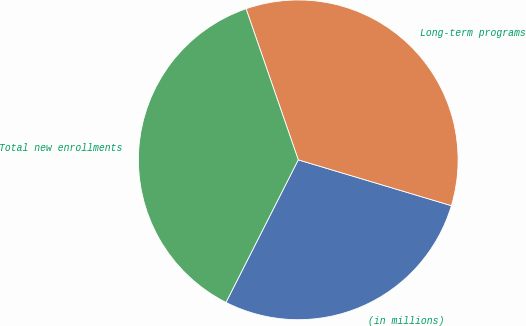Convert chart. <chart><loc_0><loc_0><loc_500><loc_500><pie_chart><fcel>(in millions)<fcel>Long-term programs<fcel>Total new enrollments<nl><fcel>27.84%<fcel>34.93%<fcel>37.24%<nl></chart> 